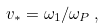<formula> <loc_0><loc_0><loc_500><loc_500>v _ { * } = \omega _ { 1 } / \omega _ { P } \, ,</formula> 